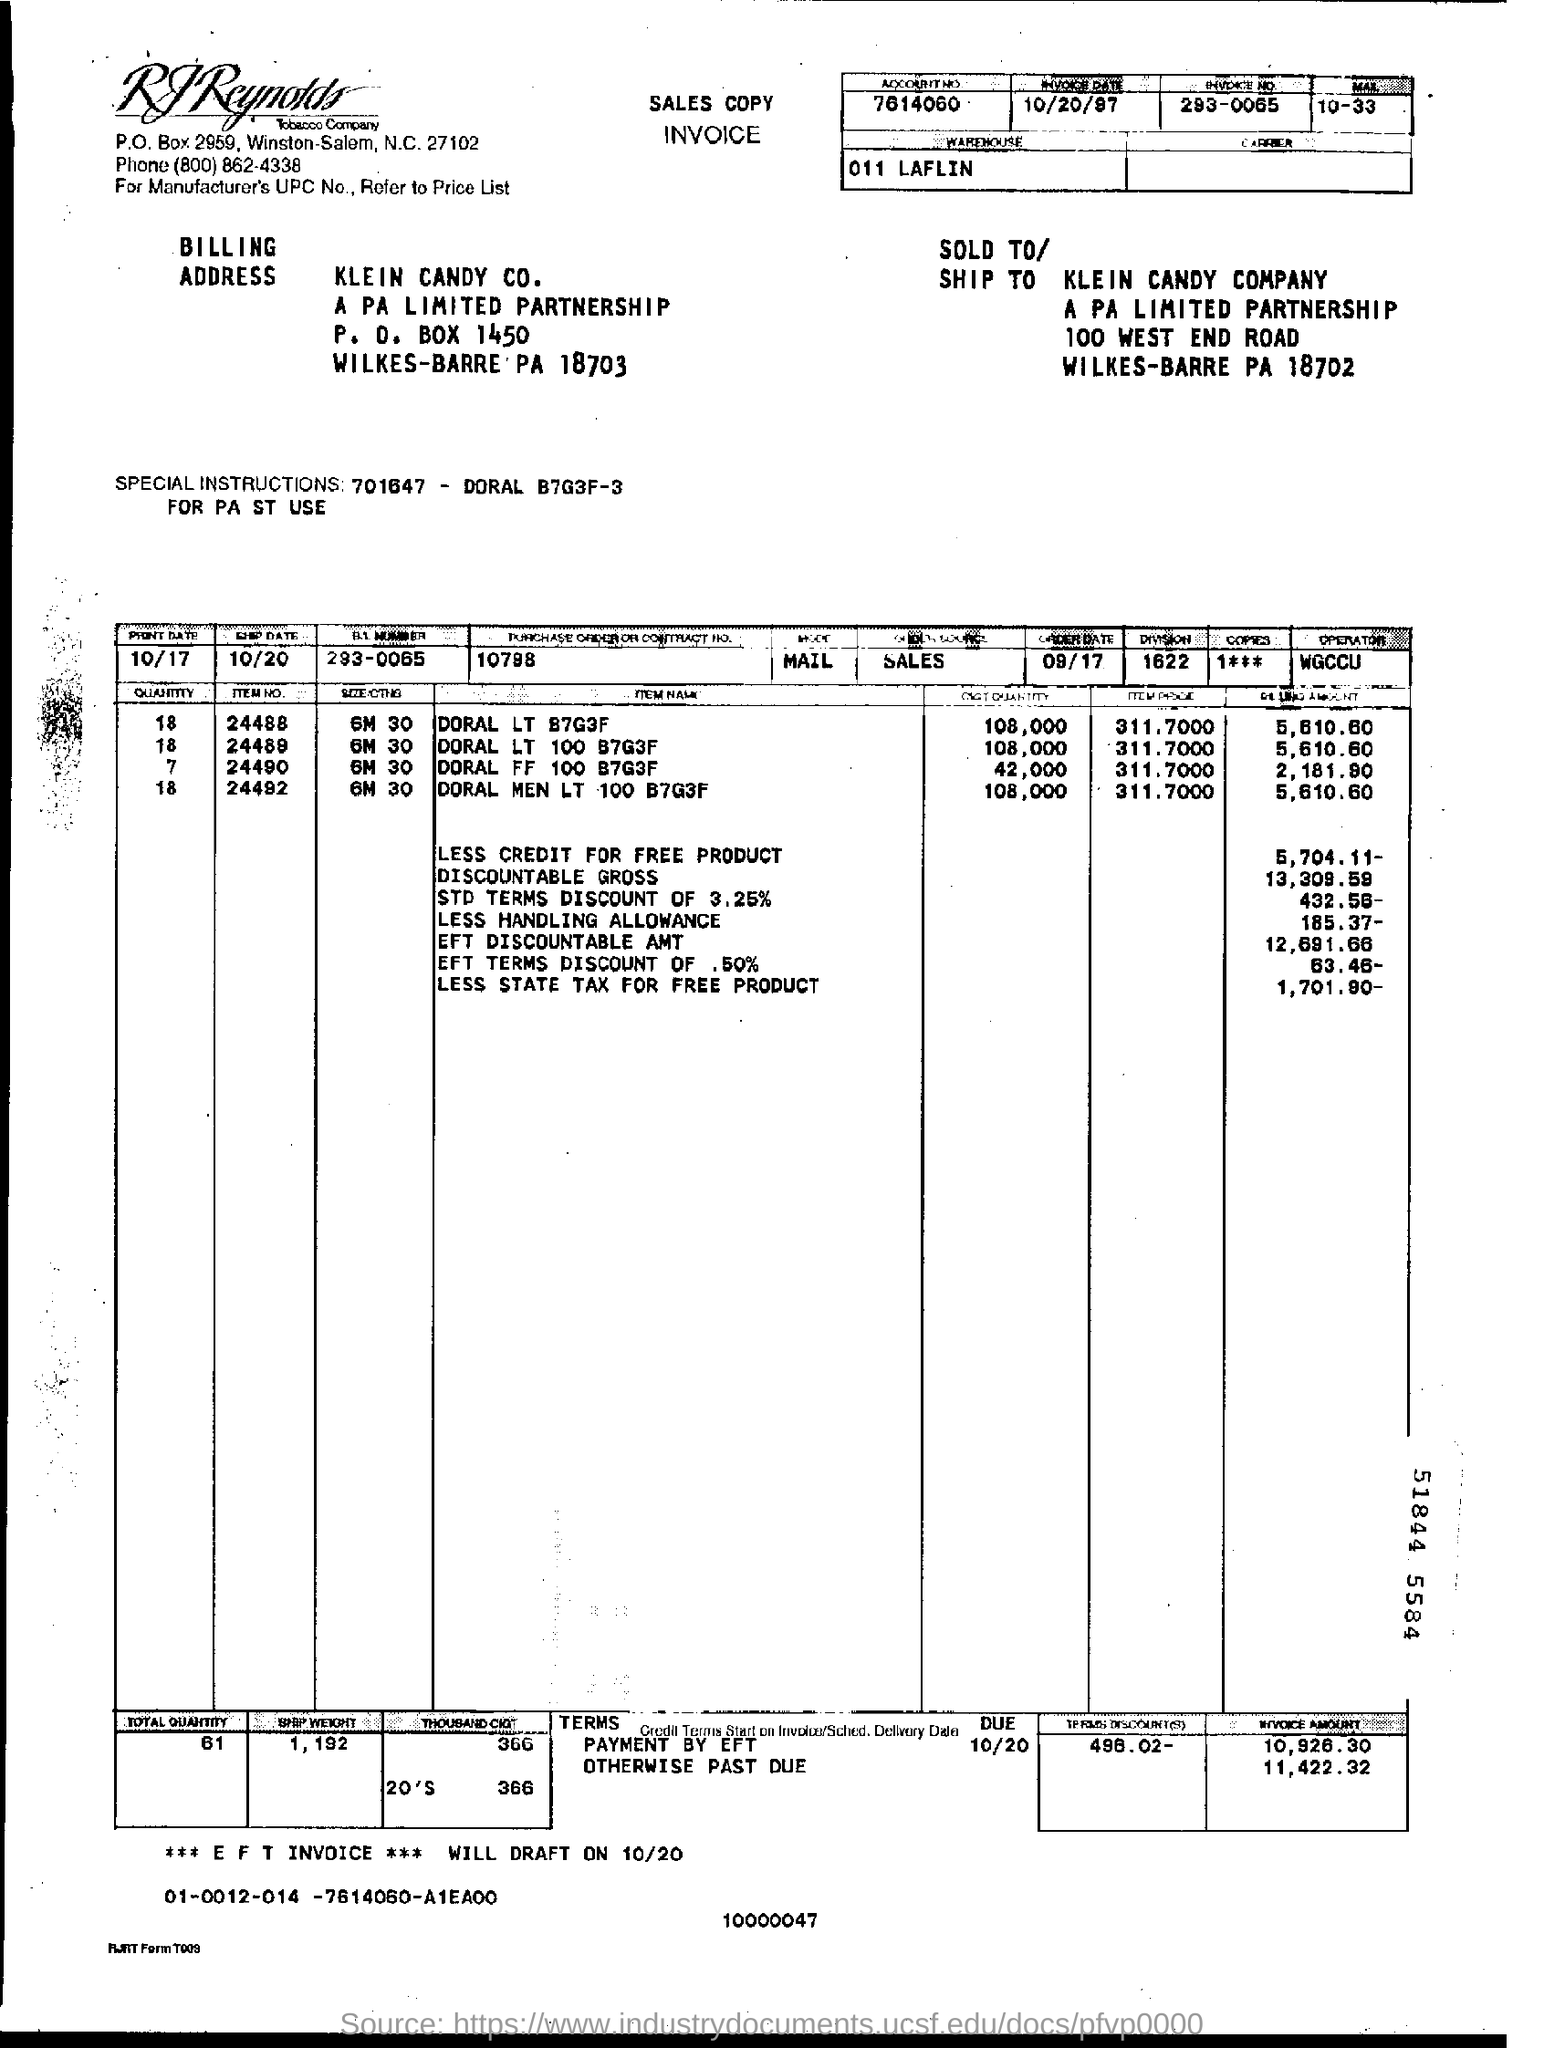Specify some key components in this picture. The payee name listed on the invoice is Klein Candy Company. The purchase order or contract number given in the invoice is 10798. The invoice date mentioned in the document is October 20, 1997. The R.J. Reynolds Tobacco Company is issuing the invoice. The invoice number mentioned in the document is 293-0065... 